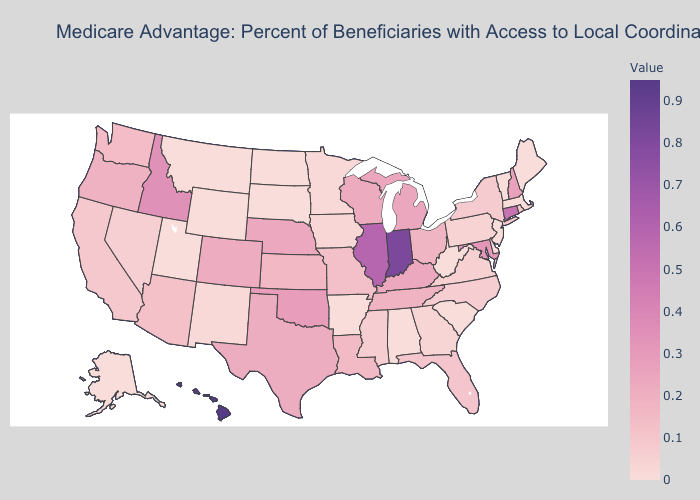Does Colorado have the lowest value in the USA?
Keep it brief. No. Does the map have missing data?
Concise answer only. No. Does Indiana have the highest value in the MidWest?
Give a very brief answer. Yes. Among the states that border Vermont , does New York have the highest value?
Quick response, please. No. Among the states that border North Carolina , which have the lowest value?
Write a very short answer. South Carolina. Which states hav the highest value in the West?
Give a very brief answer. Hawaii. Which states hav the highest value in the Northeast?
Answer briefly. Connecticut. Does Hawaii have the highest value in the USA?
Concise answer only. Yes. Does New York have the lowest value in the Northeast?
Give a very brief answer. No. Which states have the lowest value in the USA?
Give a very brief answer. Alaska, Alabama, Arkansas, Delaware, Massachusetts, Maine, Montana, North Dakota, New Jersey, South Carolina, South Dakota, Utah, Vermont, West Virginia, Wyoming. 